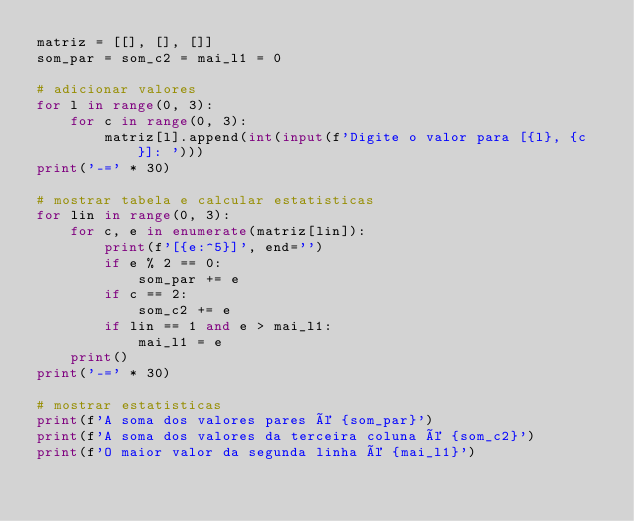<code> <loc_0><loc_0><loc_500><loc_500><_Python_>matriz = [[], [], []]
som_par = som_c2 = mai_l1 = 0

# adicionar valores
for l in range(0, 3):
    for c in range(0, 3):
        matriz[l].append(int(input(f'Digite o valor para [{l}, {c}]: ')))
print('-=' * 30)

# mostrar tabela e calcular estatisticas
for lin in range(0, 3):
    for c, e in enumerate(matriz[lin]):
        print(f'[{e:^5}]', end='')
        if e % 2 == 0:
            som_par += e
        if c == 2:
            som_c2 += e
        if lin == 1 and e > mai_l1:
            mai_l1 = e
    print()
print('-=' * 30)

# mostrar estatisticas
print(f'A soma dos valores pares é {som_par}')
print(f'A soma dos valores da terceira coluna é {som_c2}')
print(f'O maior valor da segunda linha é {mai_l1}')
</code> 